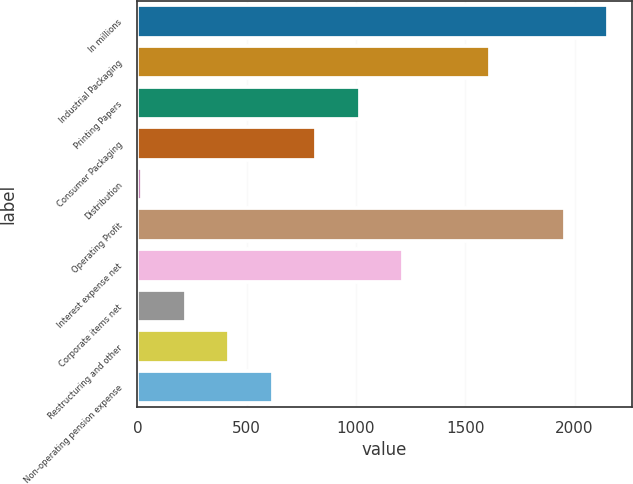Convert chart to OTSL. <chart><loc_0><loc_0><loc_500><loc_500><bar_chart><fcel>In millions<fcel>Industrial Packaging<fcel>Printing Papers<fcel>Consumer Packaging<fcel>Distribution<fcel>Operating Profit<fcel>Interest expense net<fcel>Corporate items net<fcel>Restructuring and other<fcel>Non-operating pension expense<nl><fcel>2154<fcel>1614<fcel>1017<fcel>818<fcel>22<fcel>1955<fcel>1216<fcel>221<fcel>420<fcel>619<nl></chart> 